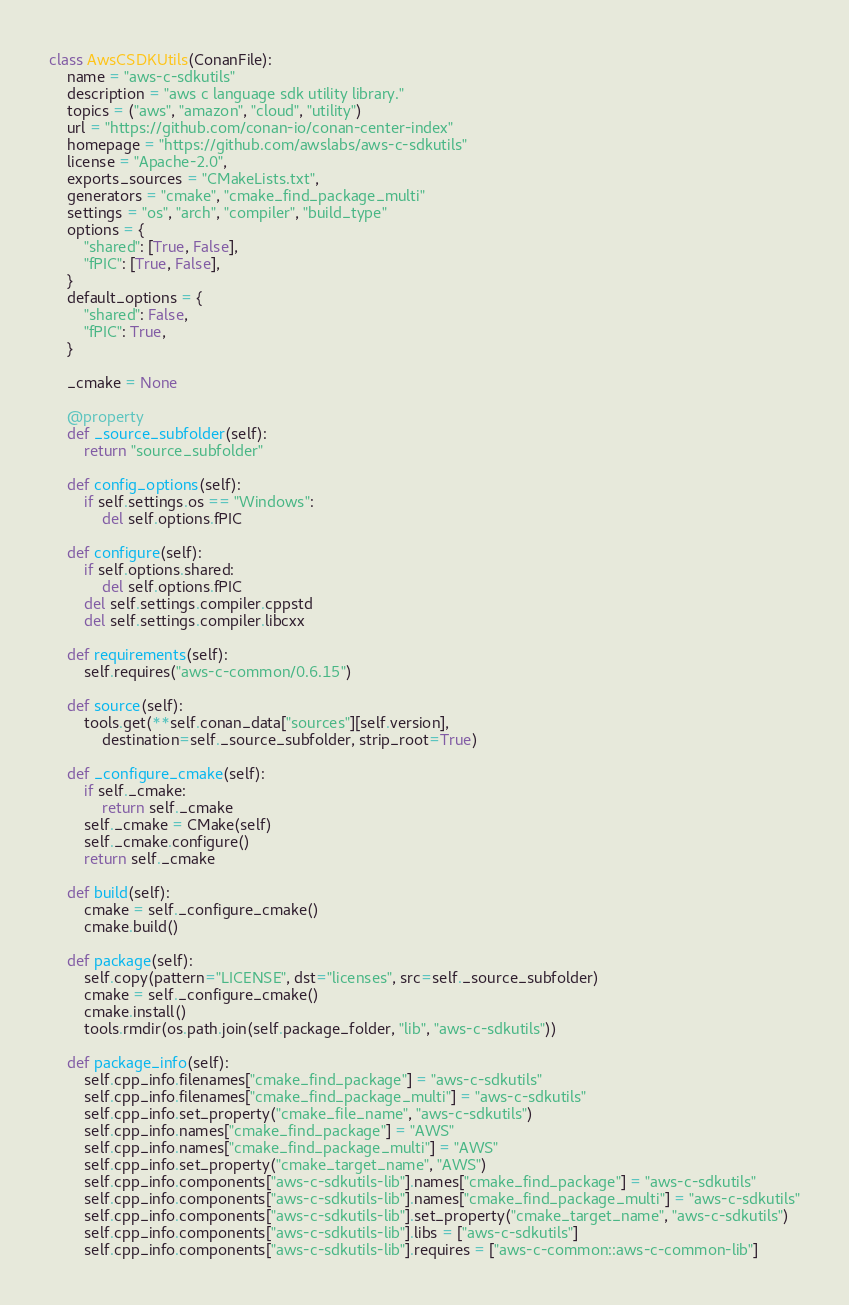<code> <loc_0><loc_0><loc_500><loc_500><_Python_>class AwsCSDKUtils(ConanFile):
    name = "aws-c-sdkutils"
    description = "aws c language sdk utility library."
    topics = ("aws", "amazon", "cloud", "utility")
    url = "https://github.com/conan-io/conan-center-index"
    homepage = "https://github.com/awslabs/aws-c-sdkutils"
    license = "Apache-2.0",
    exports_sources = "CMakeLists.txt",
    generators = "cmake", "cmake_find_package_multi"
    settings = "os", "arch", "compiler", "build_type"
    options = {
        "shared": [True, False],
        "fPIC": [True, False],
    }
    default_options = {
        "shared": False,
        "fPIC": True,
    }

    _cmake = None

    @property
    def _source_subfolder(self):
        return "source_subfolder"

    def config_options(self):
        if self.settings.os == "Windows":
            del self.options.fPIC

    def configure(self):
        if self.options.shared:
            del self.options.fPIC
        del self.settings.compiler.cppstd
        del self.settings.compiler.libcxx

    def requirements(self):
        self.requires("aws-c-common/0.6.15")

    def source(self):
        tools.get(**self.conan_data["sources"][self.version],
            destination=self._source_subfolder, strip_root=True)

    def _configure_cmake(self):
        if self._cmake:
            return self._cmake
        self._cmake = CMake(self)
        self._cmake.configure()
        return self._cmake

    def build(self):
        cmake = self._configure_cmake()
        cmake.build()

    def package(self):
        self.copy(pattern="LICENSE", dst="licenses", src=self._source_subfolder)
        cmake = self._configure_cmake()
        cmake.install()
        tools.rmdir(os.path.join(self.package_folder, "lib", "aws-c-sdkutils"))

    def package_info(self):
        self.cpp_info.filenames["cmake_find_package"] = "aws-c-sdkutils"
        self.cpp_info.filenames["cmake_find_package_multi"] = "aws-c-sdkutils"
        self.cpp_info.set_property("cmake_file_name", "aws-c-sdkutils")
        self.cpp_info.names["cmake_find_package"] = "AWS"
        self.cpp_info.names["cmake_find_package_multi"] = "AWS"
        self.cpp_info.set_property("cmake_target_name", "AWS")
        self.cpp_info.components["aws-c-sdkutils-lib"].names["cmake_find_package"] = "aws-c-sdkutils"
        self.cpp_info.components["aws-c-sdkutils-lib"].names["cmake_find_package_multi"] = "aws-c-sdkutils"
        self.cpp_info.components["aws-c-sdkutils-lib"].set_property("cmake_target_name", "aws-c-sdkutils")
        self.cpp_info.components["aws-c-sdkutils-lib"].libs = ["aws-c-sdkutils"]
        self.cpp_info.components["aws-c-sdkutils-lib"].requires = ["aws-c-common::aws-c-common-lib"]

</code> 